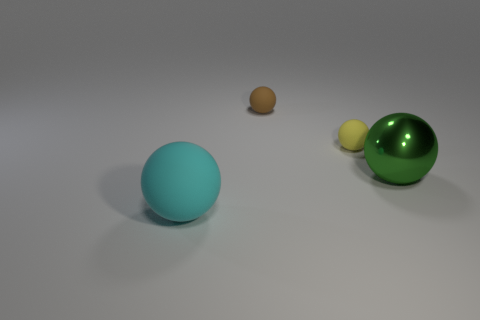Subtract all brown rubber spheres. How many spheres are left? 3 Add 3 small blue matte things. How many objects exist? 7 Subtract all brown spheres. How many spheres are left? 3 Subtract all blue blocks. How many gray balls are left? 0 Subtract all cyan cylinders. Subtract all tiny brown objects. How many objects are left? 3 Add 2 brown rubber things. How many brown rubber things are left? 3 Add 2 large gray matte spheres. How many large gray matte spheres exist? 2 Subtract 0 blue cylinders. How many objects are left? 4 Subtract 1 spheres. How many spheres are left? 3 Subtract all purple balls. Subtract all cyan blocks. How many balls are left? 4 